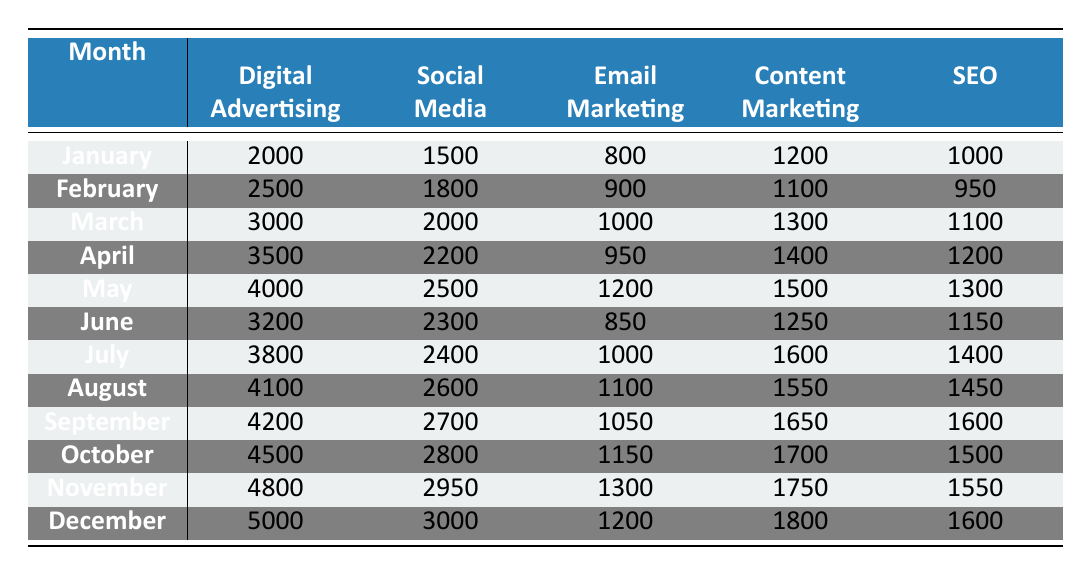What is the budget allocation for Digital Advertising in December? In the table under the month of December, the value corresponding to Digital Advertising is directly provided as 5000.
Answer: 5000 What was the highest budget allocated to Content Marketing, and in which month did it occur? By scanning the row for Content Marketing, we find the values are 1200, 1100, 1300, 1400, 1500, 1250, 1600, 1550, 1650, 1700, 1750, and 1800. The maximum value is 1800 in December.
Answer: 1800 in December What is the total budget allocated for all marketing channels in March? We sum the amounts for March: 3000 (Digital Advertising) + 2000 (Social Media) + 1000 (Email Marketing) + 1300 (Content Marketing) + 1100 (SEO) = 11400.
Answer: 11400 Did the budget for Email Marketing exceed 1200 in any month? Checking the Email Marketing values, we see they are 800, 900, 1000, 950, 1200, 850, 1000, 1100, 1050, 1150, 1300, and 1200. The value of 1300 in November is greater than 1200, confirming a "yes."
Answer: Yes In which month did the total allocation for Social Media and SEO reach 4000 or more? Adding the values for Social Media and SEO, we find combinations: In January: 1500 + 1000 = 2500, in February: 1800 + 950 = 2750, in March: 2000 + 1100 = 3100, in April: 2200 + 1200 = 3400, in May: 2500 + 1300 = 3800, in June: 2300 + 1150 = 3450, in July: 2400 + 1400 = 3800, in August: 2600 + 1450 = 4050 (exceeds 4000), in September: 2700 + 1600 = 4300 (exceeds 4000), and so on. The first occurrence is August.
Answer: August 